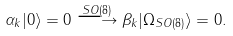Convert formula to latex. <formula><loc_0><loc_0><loc_500><loc_500>\alpha _ { k } | 0 \rangle = 0 \stackrel { S O ( 8 ) } { \longrightarrow } \beta _ { k } | \Omega _ { S O ( 8 ) } \rangle = 0 .</formula> 